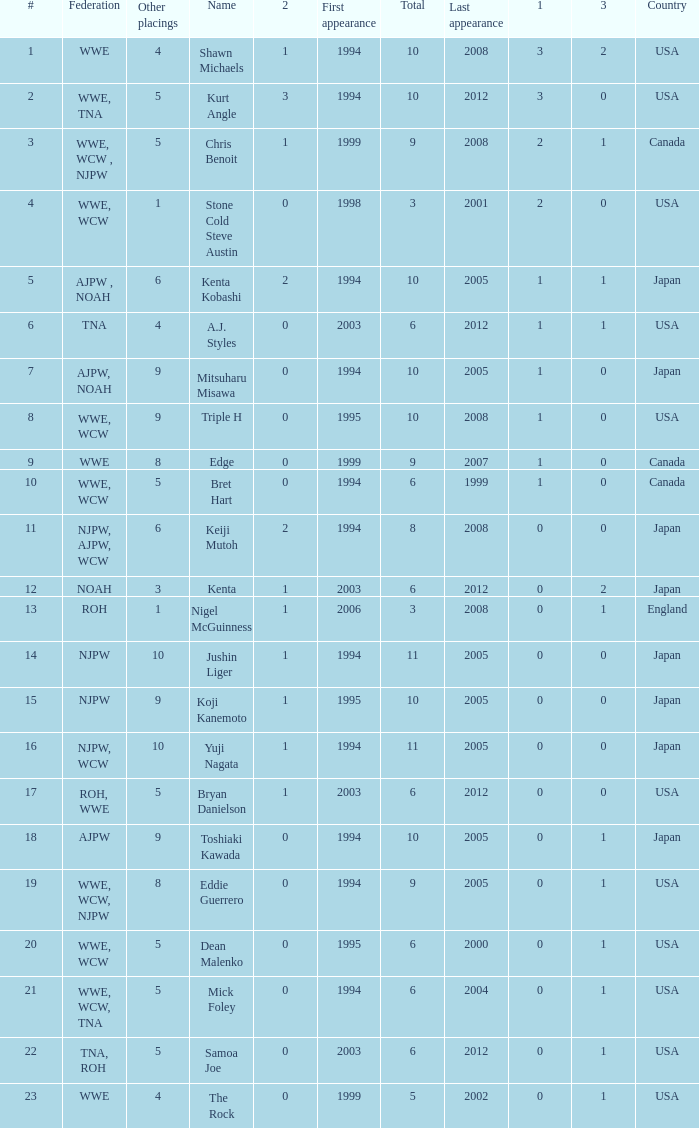What are the rank/s of Eddie Guerrero? 19.0. 